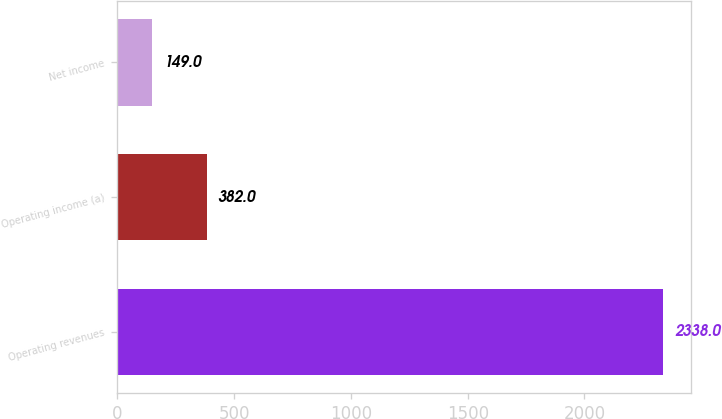Convert chart to OTSL. <chart><loc_0><loc_0><loc_500><loc_500><bar_chart><fcel>Operating revenues<fcel>Operating income (a)<fcel>Net income<nl><fcel>2338<fcel>382<fcel>149<nl></chart> 